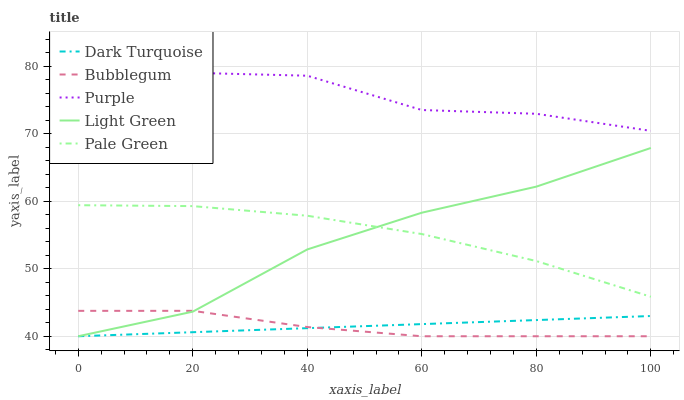Does Dark Turquoise have the minimum area under the curve?
Answer yes or no. No. Does Dark Turquoise have the maximum area under the curve?
Answer yes or no. No. Is Pale Green the smoothest?
Answer yes or no. No. Is Pale Green the roughest?
Answer yes or no. No. Does Pale Green have the lowest value?
Answer yes or no. No. Does Pale Green have the highest value?
Answer yes or no. No. Is Pale Green less than Purple?
Answer yes or no. Yes. Is Pale Green greater than Bubblegum?
Answer yes or no. Yes. Does Pale Green intersect Purple?
Answer yes or no. No. 